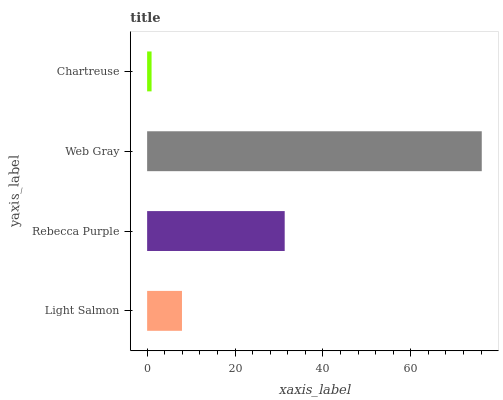Is Chartreuse the minimum?
Answer yes or no. Yes. Is Web Gray the maximum?
Answer yes or no. Yes. Is Rebecca Purple the minimum?
Answer yes or no. No. Is Rebecca Purple the maximum?
Answer yes or no. No. Is Rebecca Purple greater than Light Salmon?
Answer yes or no. Yes. Is Light Salmon less than Rebecca Purple?
Answer yes or no. Yes. Is Light Salmon greater than Rebecca Purple?
Answer yes or no. No. Is Rebecca Purple less than Light Salmon?
Answer yes or no. No. Is Rebecca Purple the high median?
Answer yes or no. Yes. Is Light Salmon the low median?
Answer yes or no. Yes. Is Light Salmon the high median?
Answer yes or no. No. Is Rebecca Purple the low median?
Answer yes or no. No. 